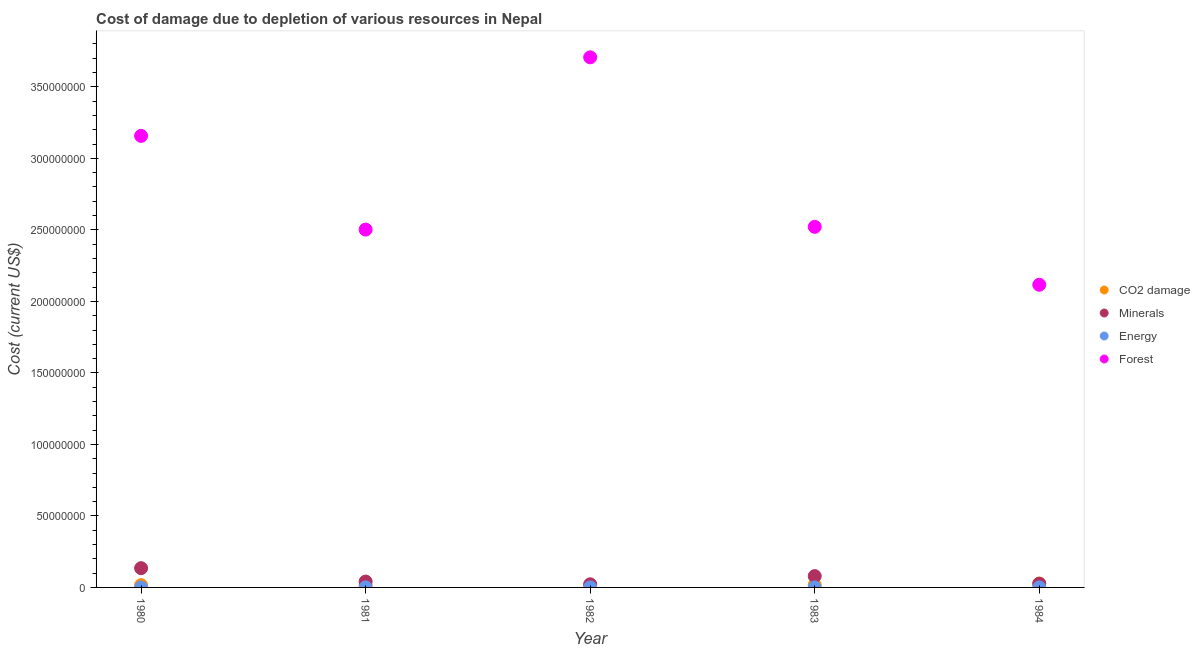How many different coloured dotlines are there?
Make the answer very short. 4. Is the number of dotlines equal to the number of legend labels?
Your answer should be compact. Yes. What is the cost of damage due to depletion of minerals in 1981?
Provide a short and direct response. 4.10e+06. Across all years, what is the maximum cost of damage due to depletion of minerals?
Offer a terse response. 1.35e+07. Across all years, what is the minimum cost of damage due to depletion of forests?
Offer a terse response. 2.12e+08. In which year was the cost of damage due to depletion of energy maximum?
Offer a terse response. 1982. In which year was the cost of damage due to depletion of coal minimum?
Keep it short and to the point. 1981. What is the total cost of damage due to depletion of minerals in the graph?
Provide a short and direct response. 3.03e+07. What is the difference between the cost of damage due to depletion of energy in 1980 and that in 1981?
Make the answer very short. -1.65e+04. What is the difference between the cost of damage due to depletion of minerals in 1981 and the cost of damage due to depletion of energy in 1984?
Offer a terse response. 4.09e+06. What is the average cost of damage due to depletion of minerals per year?
Your answer should be compact. 6.05e+06. In the year 1982, what is the difference between the cost of damage due to depletion of minerals and cost of damage due to depletion of coal?
Provide a short and direct response. 6.41e+05. In how many years, is the cost of damage due to depletion of coal greater than 270000000 US$?
Ensure brevity in your answer.  0. What is the ratio of the cost of damage due to depletion of coal in 1982 to that in 1983?
Provide a succinct answer. 0.85. What is the difference between the highest and the second highest cost of damage due to depletion of minerals?
Offer a very short reply. 5.56e+06. What is the difference between the highest and the lowest cost of damage due to depletion of energy?
Your answer should be compact. 2.25e+04. In how many years, is the cost of damage due to depletion of energy greater than the average cost of damage due to depletion of energy taken over all years?
Your answer should be compact. 2. Is it the case that in every year, the sum of the cost of damage due to depletion of coal and cost of damage due to depletion of minerals is greater than the cost of damage due to depletion of energy?
Make the answer very short. Yes. Does the cost of damage due to depletion of forests monotonically increase over the years?
Offer a very short reply. No. Is the cost of damage due to depletion of forests strictly greater than the cost of damage due to depletion of minerals over the years?
Keep it short and to the point. Yes. Is the cost of damage due to depletion of minerals strictly less than the cost of damage due to depletion of energy over the years?
Ensure brevity in your answer.  No. Does the graph contain any zero values?
Provide a succinct answer. No. Does the graph contain grids?
Make the answer very short. No. How many legend labels are there?
Your answer should be compact. 4. What is the title of the graph?
Your answer should be compact. Cost of damage due to depletion of various resources in Nepal . What is the label or title of the X-axis?
Offer a very short reply. Year. What is the label or title of the Y-axis?
Offer a very short reply. Cost (current US$). What is the Cost (current US$) in CO2 damage in 1980?
Provide a succinct answer. 1.59e+06. What is the Cost (current US$) of Minerals in 1980?
Ensure brevity in your answer.  1.35e+07. What is the Cost (current US$) of Energy in 1980?
Give a very brief answer. 1.29e+04. What is the Cost (current US$) of Forest in 1980?
Offer a very short reply. 3.16e+08. What is the Cost (current US$) of CO2 damage in 1981?
Your response must be concise. 1.47e+06. What is the Cost (current US$) of Minerals in 1981?
Your response must be concise. 4.10e+06. What is the Cost (current US$) of Energy in 1981?
Offer a terse response. 2.94e+04. What is the Cost (current US$) in Forest in 1981?
Ensure brevity in your answer.  2.50e+08. What is the Cost (current US$) in CO2 damage in 1982?
Make the answer very short. 1.54e+06. What is the Cost (current US$) of Minerals in 1982?
Provide a succinct answer. 2.18e+06. What is the Cost (current US$) in Energy in 1982?
Keep it short and to the point. 3.48e+04. What is the Cost (current US$) of Forest in 1982?
Your response must be concise. 3.71e+08. What is the Cost (current US$) of CO2 damage in 1983?
Ensure brevity in your answer.  1.81e+06. What is the Cost (current US$) of Minerals in 1983?
Provide a short and direct response. 7.91e+06. What is the Cost (current US$) of Energy in 1983?
Keep it short and to the point. 1.91e+04. What is the Cost (current US$) of Forest in 1983?
Your answer should be very brief. 2.52e+08. What is the Cost (current US$) in CO2 damage in 1984?
Your answer should be compact. 2.69e+06. What is the Cost (current US$) in Minerals in 1984?
Keep it short and to the point. 2.60e+06. What is the Cost (current US$) of Energy in 1984?
Offer a very short reply. 1.23e+04. What is the Cost (current US$) of Forest in 1984?
Your response must be concise. 2.12e+08. Across all years, what is the maximum Cost (current US$) of CO2 damage?
Ensure brevity in your answer.  2.69e+06. Across all years, what is the maximum Cost (current US$) of Minerals?
Ensure brevity in your answer.  1.35e+07. Across all years, what is the maximum Cost (current US$) in Energy?
Your answer should be very brief. 3.48e+04. Across all years, what is the maximum Cost (current US$) in Forest?
Offer a very short reply. 3.71e+08. Across all years, what is the minimum Cost (current US$) of CO2 damage?
Give a very brief answer. 1.47e+06. Across all years, what is the minimum Cost (current US$) of Minerals?
Make the answer very short. 2.18e+06. Across all years, what is the minimum Cost (current US$) in Energy?
Your answer should be very brief. 1.23e+04. Across all years, what is the minimum Cost (current US$) of Forest?
Offer a very short reply. 2.12e+08. What is the total Cost (current US$) of CO2 damage in the graph?
Make the answer very short. 9.10e+06. What is the total Cost (current US$) in Minerals in the graph?
Offer a very short reply. 3.03e+07. What is the total Cost (current US$) of Energy in the graph?
Your answer should be compact. 1.09e+05. What is the total Cost (current US$) of Forest in the graph?
Your response must be concise. 1.40e+09. What is the difference between the Cost (current US$) in CO2 damage in 1980 and that in 1981?
Your answer should be compact. 1.16e+05. What is the difference between the Cost (current US$) of Minerals in 1980 and that in 1981?
Provide a succinct answer. 9.37e+06. What is the difference between the Cost (current US$) in Energy in 1980 and that in 1981?
Make the answer very short. -1.65e+04. What is the difference between the Cost (current US$) of Forest in 1980 and that in 1981?
Keep it short and to the point. 6.55e+07. What is the difference between the Cost (current US$) in CO2 damage in 1980 and that in 1982?
Ensure brevity in your answer.  4.47e+04. What is the difference between the Cost (current US$) in Minerals in 1980 and that in 1982?
Offer a terse response. 1.13e+07. What is the difference between the Cost (current US$) of Energy in 1980 and that in 1982?
Offer a terse response. -2.19e+04. What is the difference between the Cost (current US$) in Forest in 1980 and that in 1982?
Provide a succinct answer. -5.49e+07. What is the difference between the Cost (current US$) in CO2 damage in 1980 and that in 1983?
Provide a succinct answer. -2.22e+05. What is the difference between the Cost (current US$) in Minerals in 1980 and that in 1983?
Your answer should be compact. 5.56e+06. What is the difference between the Cost (current US$) in Energy in 1980 and that in 1983?
Provide a succinct answer. -6195.2. What is the difference between the Cost (current US$) of Forest in 1980 and that in 1983?
Your answer should be very brief. 6.36e+07. What is the difference between the Cost (current US$) of CO2 damage in 1980 and that in 1984?
Provide a short and direct response. -1.11e+06. What is the difference between the Cost (current US$) in Minerals in 1980 and that in 1984?
Give a very brief answer. 1.09e+07. What is the difference between the Cost (current US$) in Energy in 1980 and that in 1984?
Keep it short and to the point. 561.95. What is the difference between the Cost (current US$) in Forest in 1980 and that in 1984?
Your answer should be very brief. 1.04e+08. What is the difference between the Cost (current US$) in CO2 damage in 1981 and that in 1982?
Offer a terse response. -7.13e+04. What is the difference between the Cost (current US$) of Minerals in 1981 and that in 1982?
Keep it short and to the point. 1.92e+06. What is the difference between the Cost (current US$) of Energy in 1981 and that in 1982?
Ensure brevity in your answer.  -5470.79. What is the difference between the Cost (current US$) in Forest in 1981 and that in 1982?
Give a very brief answer. -1.20e+08. What is the difference between the Cost (current US$) of CO2 damage in 1981 and that in 1983?
Provide a short and direct response. -3.39e+05. What is the difference between the Cost (current US$) in Minerals in 1981 and that in 1983?
Your answer should be compact. -3.80e+06. What is the difference between the Cost (current US$) in Energy in 1981 and that in 1983?
Make the answer very short. 1.03e+04. What is the difference between the Cost (current US$) in Forest in 1981 and that in 1983?
Provide a short and direct response. -1.92e+06. What is the difference between the Cost (current US$) in CO2 damage in 1981 and that in 1984?
Your answer should be very brief. -1.22e+06. What is the difference between the Cost (current US$) of Minerals in 1981 and that in 1984?
Give a very brief answer. 1.50e+06. What is the difference between the Cost (current US$) in Energy in 1981 and that in 1984?
Provide a short and direct response. 1.70e+04. What is the difference between the Cost (current US$) in Forest in 1981 and that in 1984?
Offer a very short reply. 3.86e+07. What is the difference between the Cost (current US$) of CO2 damage in 1982 and that in 1983?
Ensure brevity in your answer.  -2.67e+05. What is the difference between the Cost (current US$) of Minerals in 1982 and that in 1983?
Provide a short and direct response. -5.72e+06. What is the difference between the Cost (current US$) of Energy in 1982 and that in 1983?
Provide a succinct answer. 1.57e+04. What is the difference between the Cost (current US$) in Forest in 1982 and that in 1983?
Your answer should be compact. 1.19e+08. What is the difference between the Cost (current US$) of CO2 damage in 1982 and that in 1984?
Offer a terse response. -1.15e+06. What is the difference between the Cost (current US$) of Minerals in 1982 and that in 1984?
Offer a terse response. -4.16e+05. What is the difference between the Cost (current US$) in Energy in 1982 and that in 1984?
Ensure brevity in your answer.  2.25e+04. What is the difference between the Cost (current US$) in Forest in 1982 and that in 1984?
Provide a short and direct response. 1.59e+08. What is the difference between the Cost (current US$) in CO2 damage in 1983 and that in 1984?
Your response must be concise. -8.86e+05. What is the difference between the Cost (current US$) in Minerals in 1983 and that in 1984?
Provide a short and direct response. 5.31e+06. What is the difference between the Cost (current US$) of Energy in 1983 and that in 1984?
Offer a very short reply. 6757.15. What is the difference between the Cost (current US$) in Forest in 1983 and that in 1984?
Your response must be concise. 4.05e+07. What is the difference between the Cost (current US$) in CO2 damage in 1980 and the Cost (current US$) in Minerals in 1981?
Your answer should be very brief. -2.52e+06. What is the difference between the Cost (current US$) in CO2 damage in 1980 and the Cost (current US$) in Energy in 1981?
Provide a succinct answer. 1.56e+06. What is the difference between the Cost (current US$) of CO2 damage in 1980 and the Cost (current US$) of Forest in 1981?
Provide a short and direct response. -2.49e+08. What is the difference between the Cost (current US$) in Minerals in 1980 and the Cost (current US$) in Energy in 1981?
Offer a very short reply. 1.34e+07. What is the difference between the Cost (current US$) in Minerals in 1980 and the Cost (current US$) in Forest in 1981?
Your answer should be compact. -2.37e+08. What is the difference between the Cost (current US$) in Energy in 1980 and the Cost (current US$) in Forest in 1981?
Provide a short and direct response. -2.50e+08. What is the difference between the Cost (current US$) in CO2 damage in 1980 and the Cost (current US$) in Minerals in 1982?
Keep it short and to the point. -5.97e+05. What is the difference between the Cost (current US$) in CO2 damage in 1980 and the Cost (current US$) in Energy in 1982?
Ensure brevity in your answer.  1.55e+06. What is the difference between the Cost (current US$) in CO2 damage in 1980 and the Cost (current US$) in Forest in 1982?
Provide a short and direct response. -3.69e+08. What is the difference between the Cost (current US$) in Minerals in 1980 and the Cost (current US$) in Energy in 1982?
Keep it short and to the point. 1.34e+07. What is the difference between the Cost (current US$) of Minerals in 1980 and the Cost (current US$) of Forest in 1982?
Ensure brevity in your answer.  -3.57e+08. What is the difference between the Cost (current US$) of Energy in 1980 and the Cost (current US$) of Forest in 1982?
Offer a terse response. -3.71e+08. What is the difference between the Cost (current US$) in CO2 damage in 1980 and the Cost (current US$) in Minerals in 1983?
Provide a succinct answer. -6.32e+06. What is the difference between the Cost (current US$) of CO2 damage in 1980 and the Cost (current US$) of Energy in 1983?
Make the answer very short. 1.57e+06. What is the difference between the Cost (current US$) of CO2 damage in 1980 and the Cost (current US$) of Forest in 1983?
Your answer should be compact. -2.51e+08. What is the difference between the Cost (current US$) of Minerals in 1980 and the Cost (current US$) of Energy in 1983?
Offer a very short reply. 1.34e+07. What is the difference between the Cost (current US$) in Minerals in 1980 and the Cost (current US$) in Forest in 1983?
Keep it short and to the point. -2.39e+08. What is the difference between the Cost (current US$) of Energy in 1980 and the Cost (current US$) of Forest in 1983?
Your answer should be compact. -2.52e+08. What is the difference between the Cost (current US$) in CO2 damage in 1980 and the Cost (current US$) in Minerals in 1984?
Keep it short and to the point. -1.01e+06. What is the difference between the Cost (current US$) of CO2 damage in 1980 and the Cost (current US$) of Energy in 1984?
Your answer should be very brief. 1.57e+06. What is the difference between the Cost (current US$) of CO2 damage in 1980 and the Cost (current US$) of Forest in 1984?
Offer a terse response. -2.10e+08. What is the difference between the Cost (current US$) in Minerals in 1980 and the Cost (current US$) in Energy in 1984?
Give a very brief answer. 1.35e+07. What is the difference between the Cost (current US$) of Minerals in 1980 and the Cost (current US$) of Forest in 1984?
Your response must be concise. -1.98e+08. What is the difference between the Cost (current US$) in Energy in 1980 and the Cost (current US$) in Forest in 1984?
Keep it short and to the point. -2.12e+08. What is the difference between the Cost (current US$) in CO2 damage in 1981 and the Cost (current US$) in Minerals in 1982?
Your response must be concise. -7.13e+05. What is the difference between the Cost (current US$) of CO2 damage in 1981 and the Cost (current US$) of Energy in 1982?
Keep it short and to the point. 1.43e+06. What is the difference between the Cost (current US$) of CO2 damage in 1981 and the Cost (current US$) of Forest in 1982?
Provide a succinct answer. -3.69e+08. What is the difference between the Cost (current US$) in Minerals in 1981 and the Cost (current US$) in Energy in 1982?
Provide a short and direct response. 4.07e+06. What is the difference between the Cost (current US$) in Minerals in 1981 and the Cost (current US$) in Forest in 1982?
Provide a short and direct response. -3.67e+08. What is the difference between the Cost (current US$) of Energy in 1981 and the Cost (current US$) of Forest in 1982?
Your answer should be compact. -3.71e+08. What is the difference between the Cost (current US$) of CO2 damage in 1981 and the Cost (current US$) of Minerals in 1983?
Give a very brief answer. -6.44e+06. What is the difference between the Cost (current US$) of CO2 damage in 1981 and the Cost (current US$) of Energy in 1983?
Your answer should be very brief. 1.45e+06. What is the difference between the Cost (current US$) in CO2 damage in 1981 and the Cost (current US$) in Forest in 1983?
Give a very brief answer. -2.51e+08. What is the difference between the Cost (current US$) in Minerals in 1981 and the Cost (current US$) in Energy in 1983?
Your answer should be very brief. 4.08e+06. What is the difference between the Cost (current US$) of Minerals in 1981 and the Cost (current US$) of Forest in 1983?
Make the answer very short. -2.48e+08. What is the difference between the Cost (current US$) in Energy in 1981 and the Cost (current US$) in Forest in 1983?
Offer a terse response. -2.52e+08. What is the difference between the Cost (current US$) of CO2 damage in 1981 and the Cost (current US$) of Minerals in 1984?
Offer a very short reply. -1.13e+06. What is the difference between the Cost (current US$) of CO2 damage in 1981 and the Cost (current US$) of Energy in 1984?
Make the answer very short. 1.46e+06. What is the difference between the Cost (current US$) in CO2 damage in 1981 and the Cost (current US$) in Forest in 1984?
Your response must be concise. -2.10e+08. What is the difference between the Cost (current US$) of Minerals in 1981 and the Cost (current US$) of Energy in 1984?
Provide a short and direct response. 4.09e+06. What is the difference between the Cost (current US$) in Minerals in 1981 and the Cost (current US$) in Forest in 1984?
Ensure brevity in your answer.  -2.08e+08. What is the difference between the Cost (current US$) of Energy in 1981 and the Cost (current US$) of Forest in 1984?
Offer a very short reply. -2.12e+08. What is the difference between the Cost (current US$) of CO2 damage in 1982 and the Cost (current US$) of Minerals in 1983?
Your answer should be very brief. -6.36e+06. What is the difference between the Cost (current US$) in CO2 damage in 1982 and the Cost (current US$) in Energy in 1983?
Make the answer very short. 1.52e+06. What is the difference between the Cost (current US$) in CO2 damage in 1982 and the Cost (current US$) in Forest in 1983?
Make the answer very short. -2.51e+08. What is the difference between the Cost (current US$) of Minerals in 1982 and the Cost (current US$) of Energy in 1983?
Provide a succinct answer. 2.16e+06. What is the difference between the Cost (current US$) of Minerals in 1982 and the Cost (current US$) of Forest in 1983?
Ensure brevity in your answer.  -2.50e+08. What is the difference between the Cost (current US$) of Energy in 1982 and the Cost (current US$) of Forest in 1983?
Keep it short and to the point. -2.52e+08. What is the difference between the Cost (current US$) in CO2 damage in 1982 and the Cost (current US$) in Minerals in 1984?
Offer a very short reply. -1.06e+06. What is the difference between the Cost (current US$) in CO2 damage in 1982 and the Cost (current US$) in Energy in 1984?
Offer a terse response. 1.53e+06. What is the difference between the Cost (current US$) of CO2 damage in 1982 and the Cost (current US$) of Forest in 1984?
Provide a short and direct response. -2.10e+08. What is the difference between the Cost (current US$) of Minerals in 1982 and the Cost (current US$) of Energy in 1984?
Offer a very short reply. 2.17e+06. What is the difference between the Cost (current US$) in Minerals in 1982 and the Cost (current US$) in Forest in 1984?
Provide a succinct answer. -2.09e+08. What is the difference between the Cost (current US$) of Energy in 1982 and the Cost (current US$) of Forest in 1984?
Make the answer very short. -2.12e+08. What is the difference between the Cost (current US$) in CO2 damage in 1983 and the Cost (current US$) in Minerals in 1984?
Provide a short and direct response. -7.90e+05. What is the difference between the Cost (current US$) of CO2 damage in 1983 and the Cost (current US$) of Energy in 1984?
Your response must be concise. 1.80e+06. What is the difference between the Cost (current US$) in CO2 damage in 1983 and the Cost (current US$) in Forest in 1984?
Your answer should be compact. -2.10e+08. What is the difference between the Cost (current US$) in Minerals in 1983 and the Cost (current US$) in Energy in 1984?
Provide a succinct answer. 7.89e+06. What is the difference between the Cost (current US$) in Minerals in 1983 and the Cost (current US$) in Forest in 1984?
Offer a very short reply. -2.04e+08. What is the difference between the Cost (current US$) of Energy in 1983 and the Cost (current US$) of Forest in 1984?
Offer a terse response. -2.12e+08. What is the average Cost (current US$) of CO2 damage per year?
Offer a very short reply. 1.82e+06. What is the average Cost (current US$) of Minerals per year?
Keep it short and to the point. 6.05e+06. What is the average Cost (current US$) of Energy per year?
Ensure brevity in your answer.  2.17e+04. What is the average Cost (current US$) in Forest per year?
Keep it short and to the point. 2.80e+08. In the year 1980, what is the difference between the Cost (current US$) of CO2 damage and Cost (current US$) of Minerals?
Make the answer very short. -1.19e+07. In the year 1980, what is the difference between the Cost (current US$) of CO2 damage and Cost (current US$) of Energy?
Your response must be concise. 1.57e+06. In the year 1980, what is the difference between the Cost (current US$) in CO2 damage and Cost (current US$) in Forest?
Make the answer very short. -3.14e+08. In the year 1980, what is the difference between the Cost (current US$) of Minerals and Cost (current US$) of Energy?
Keep it short and to the point. 1.35e+07. In the year 1980, what is the difference between the Cost (current US$) of Minerals and Cost (current US$) of Forest?
Offer a terse response. -3.02e+08. In the year 1980, what is the difference between the Cost (current US$) in Energy and Cost (current US$) in Forest?
Offer a very short reply. -3.16e+08. In the year 1981, what is the difference between the Cost (current US$) in CO2 damage and Cost (current US$) in Minerals?
Your answer should be very brief. -2.63e+06. In the year 1981, what is the difference between the Cost (current US$) of CO2 damage and Cost (current US$) of Energy?
Provide a short and direct response. 1.44e+06. In the year 1981, what is the difference between the Cost (current US$) of CO2 damage and Cost (current US$) of Forest?
Provide a short and direct response. -2.49e+08. In the year 1981, what is the difference between the Cost (current US$) in Minerals and Cost (current US$) in Energy?
Keep it short and to the point. 4.07e+06. In the year 1981, what is the difference between the Cost (current US$) in Minerals and Cost (current US$) in Forest?
Make the answer very short. -2.46e+08. In the year 1981, what is the difference between the Cost (current US$) of Energy and Cost (current US$) of Forest?
Ensure brevity in your answer.  -2.50e+08. In the year 1982, what is the difference between the Cost (current US$) of CO2 damage and Cost (current US$) of Minerals?
Make the answer very short. -6.41e+05. In the year 1982, what is the difference between the Cost (current US$) of CO2 damage and Cost (current US$) of Energy?
Keep it short and to the point. 1.51e+06. In the year 1982, what is the difference between the Cost (current US$) of CO2 damage and Cost (current US$) of Forest?
Provide a succinct answer. -3.69e+08. In the year 1982, what is the difference between the Cost (current US$) of Minerals and Cost (current US$) of Energy?
Keep it short and to the point. 2.15e+06. In the year 1982, what is the difference between the Cost (current US$) in Minerals and Cost (current US$) in Forest?
Make the answer very short. -3.68e+08. In the year 1982, what is the difference between the Cost (current US$) of Energy and Cost (current US$) of Forest?
Make the answer very short. -3.71e+08. In the year 1983, what is the difference between the Cost (current US$) in CO2 damage and Cost (current US$) in Minerals?
Make the answer very short. -6.10e+06. In the year 1983, what is the difference between the Cost (current US$) in CO2 damage and Cost (current US$) in Energy?
Provide a short and direct response. 1.79e+06. In the year 1983, what is the difference between the Cost (current US$) of CO2 damage and Cost (current US$) of Forest?
Provide a short and direct response. -2.50e+08. In the year 1983, what is the difference between the Cost (current US$) in Minerals and Cost (current US$) in Energy?
Offer a very short reply. 7.89e+06. In the year 1983, what is the difference between the Cost (current US$) in Minerals and Cost (current US$) in Forest?
Your answer should be very brief. -2.44e+08. In the year 1983, what is the difference between the Cost (current US$) of Energy and Cost (current US$) of Forest?
Keep it short and to the point. -2.52e+08. In the year 1984, what is the difference between the Cost (current US$) of CO2 damage and Cost (current US$) of Minerals?
Make the answer very short. 9.57e+04. In the year 1984, what is the difference between the Cost (current US$) of CO2 damage and Cost (current US$) of Energy?
Your response must be concise. 2.68e+06. In the year 1984, what is the difference between the Cost (current US$) of CO2 damage and Cost (current US$) of Forest?
Your answer should be very brief. -2.09e+08. In the year 1984, what is the difference between the Cost (current US$) of Minerals and Cost (current US$) of Energy?
Your answer should be compact. 2.59e+06. In the year 1984, what is the difference between the Cost (current US$) of Minerals and Cost (current US$) of Forest?
Offer a terse response. -2.09e+08. In the year 1984, what is the difference between the Cost (current US$) in Energy and Cost (current US$) in Forest?
Ensure brevity in your answer.  -2.12e+08. What is the ratio of the Cost (current US$) in CO2 damage in 1980 to that in 1981?
Keep it short and to the point. 1.08. What is the ratio of the Cost (current US$) in Minerals in 1980 to that in 1981?
Offer a terse response. 3.28. What is the ratio of the Cost (current US$) of Energy in 1980 to that in 1981?
Give a very brief answer. 0.44. What is the ratio of the Cost (current US$) of Forest in 1980 to that in 1981?
Your answer should be very brief. 1.26. What is the ratio of the Cost (current US$) in CO2 damage in 1980 to that in 1982?
Your response must be concise. 1.03. What is the ratio of the Cost (current US$) of Minerals in 1980 to that in 1982?
Your response must be concise. 6.17. What is the ratio of the Cost (current US$) in Energy in 1980 to that in 1982?
Offer a very short reply. 0.37. What is the ratio of the Cost (current US$) in Forest in 1980 to that in 1982?
Your answer should be very brief. 0.85. What is the ratio of the Cost (current US$) of CO2 damage in 1980 to that in 1983?
Offer a terse response. 0.88. What is the ratio of the Cost (current US$) of Minerals in 1980 to that in 1983?
Your answer should be compact. 1.7. What is the ratio of the Cost (current US$) in Energy in 1980 to that in 1983?
Provide a short and direct response. 0.68. What is the ratio of the Cost (current US$) in Forest in 1980 to that in 1983?
Give a very brief answer. 1.25. What is the ratio of the Cost (current US$) in CO2 damage in 1980 to that in 1984?
Make the answer very short. 0.59. What is the ratio of the Cost (current US$) of Minerals in 1980 to that in 1984?
Your answer should be very brief. 5.18. What is the ratio of the Cost (current US$) in Energy in 1980 to that in 1984?
Make the answer very short. 1.05. What is the ratio of the Cost (current US$) of Forest in 1980 to that in 1984?
Offer a terse response. 1.49. What is the ratio of the Cost (current US$) in CO2 damage in 1981 to that in 1982?
Provide a succinct answer. 0.95. What is the ratio of the Cost (current US$) in Minerals in 1981 to that in 1982?
Offer a terse response. 1.88. What is the ratio of the Cost (current US$) of Energy in 1981 to that in 1982?
Offer a very short reply. 0.84. What is the ratio of the Cost (current US$) of Forest in 1981 to that in 1982?
Keep it short and to the point. 0.68. What is the ratio of the Cost (current US$) in CO2 damage in 1981 to that in 1983?
Give a very brief answer. 0.81. What is the ratio of the Cost (current US$) in Minerals in 1981 to that in 1983?
Your answer should be compact. 0.52. What is the ratio of the Cost (current US$) of Energy in 1981 to that in 1983?
Ensure brevity in your answer.  1.54. What is the ratio of the Cost (current US$) of CO2 damage in 1981 to that in 1984?
Keep it short and to the point. 0.55. What is the ratio of the Cost (current US$) in Minerals in 1981 to that in 1984?
Your answer should be very brief. 1.58. What is the ratio of the Cost (current US$) of Energy in 1981 to that in 1984?
Provide a succinct answer. 2.38. What is the ratio of the Cost (current US$) of Forest in 1981 to that in 1984?
Your answer should be compact. 1.18. What is the ratio of the Cost (current US$) in CO2 damage in 1982 to that in 1983?
Offer a terse response. 0.85. What is the ratio of the Cost (current US$) of Minerals in 1982 to that in 1983?
Ensure brevity in your answer.  0.28. What is the ratio of the Cost (current US$) in Energy in 1982 to that in 1983?
Your answer should be compact. 1.82. What is the ratio of the Cost (current US$) in Forest in 1982 to that in 1983?
Your answer should be compact. 1.47. What is the ratio of the Cost (current US$) in CO2 damage in 1982 to that in 1984?
Ensure brevity in your answer.  0.57. What is the ratio of the Cost (current US$) of Minerals in 1982 to that in 1984?
Provide a succinct answer. 0.84. What is the ratio of the Cost (current US$) of Energy in 1982 to that in 1984?
Offer a very short reply. 2.82. What is the ratio of the Cost (current US$) of Forest in 1982 to that in 1984?
Your answer should be very brief. 1.75. What is the ratio of the Cost (current US$) of CO2 damage in 1983 to that in 1984?
Offer a terse response. 0.67. What is the ratio of the Cost (current US$) in Minerals in 1983 to that in 1984?
Offer a terse response. 3.04. What is the ratio of the Cost (current US$) in Energy in 1983 to that in 1984?
Provide a short and direct response. 1.55. What is the ratio of the Cost (current US$) in Forest in 1983 to that in 1984?
Your response must be concise. 1.19. What is the difference between the highest and the second highest Cost (current US$) of CO2 damage?
Your answer should be compact. 8.86e+05. What is the difference between the highest and the second highest Cost (current US$) of Minerals?
Keep it short and to the point. 5.56e+06. What is the difference between the highest and the second highest Cost (current US$) of Energy?
Give a very brief answer. 5470.79. What is the difference between the highest and the second highest Cost (current US$) of Forest?
Ensure brevity in your answer.  5.49e+07. What is the difference between the highest and the lowest Cost (current US$) of CO2 damage?
Keep it short and to the point. 1.22e+06. What is the difference between the highest and the lowest Cost (current US$) of Minerals?
Offer a terse response. 1.13e+07. What is the difference between the highest and the lowest Cost (current US$) of Energy?
Keep it short and to the point. 2.25e+04. What is the difference between the highest and the lowest Cost (current US$) in Forest?
Your answer should be very brief. 1.59e+08. 